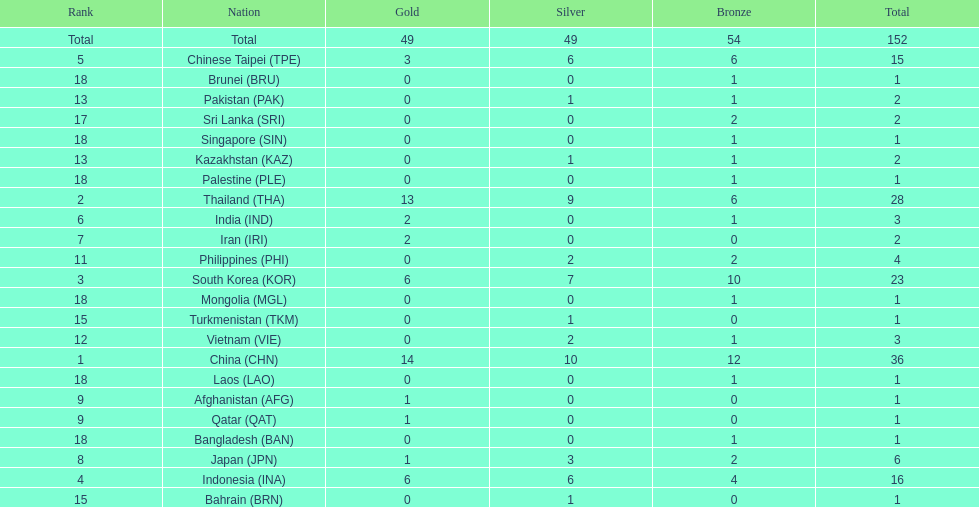How many nations won no silver medals at all? 11. 